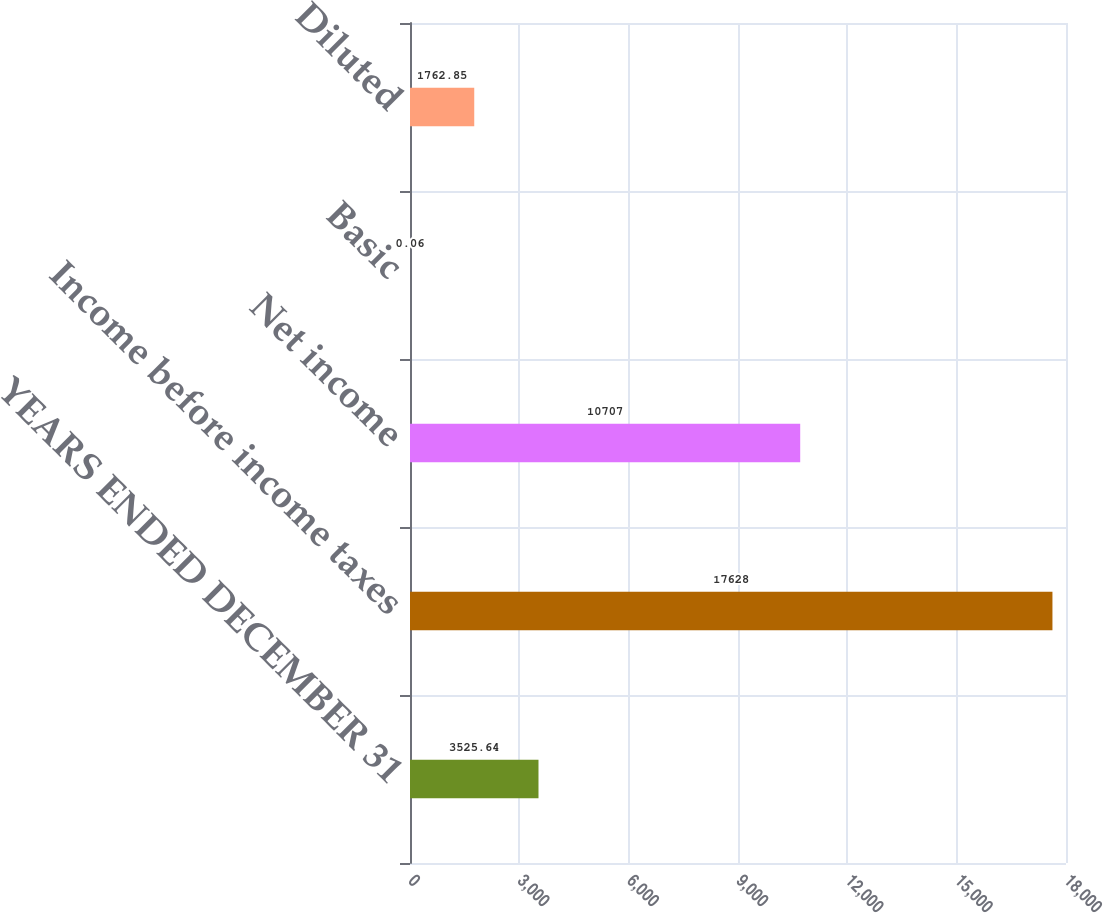Convert chart to OTSL. <chart><loc_0><loc_0><loc_500><loc_500><bar_chart><fcel>YEARS ENDED DECEMBER 31<fcel>Income before income taxes<fcel>Net income<fcel>Basic<fcel>Diluted<nl><fcel>3525.64<fcel>17628<fcel>10707<fcel>0.06<fcel>1762.85<nl></chart> 